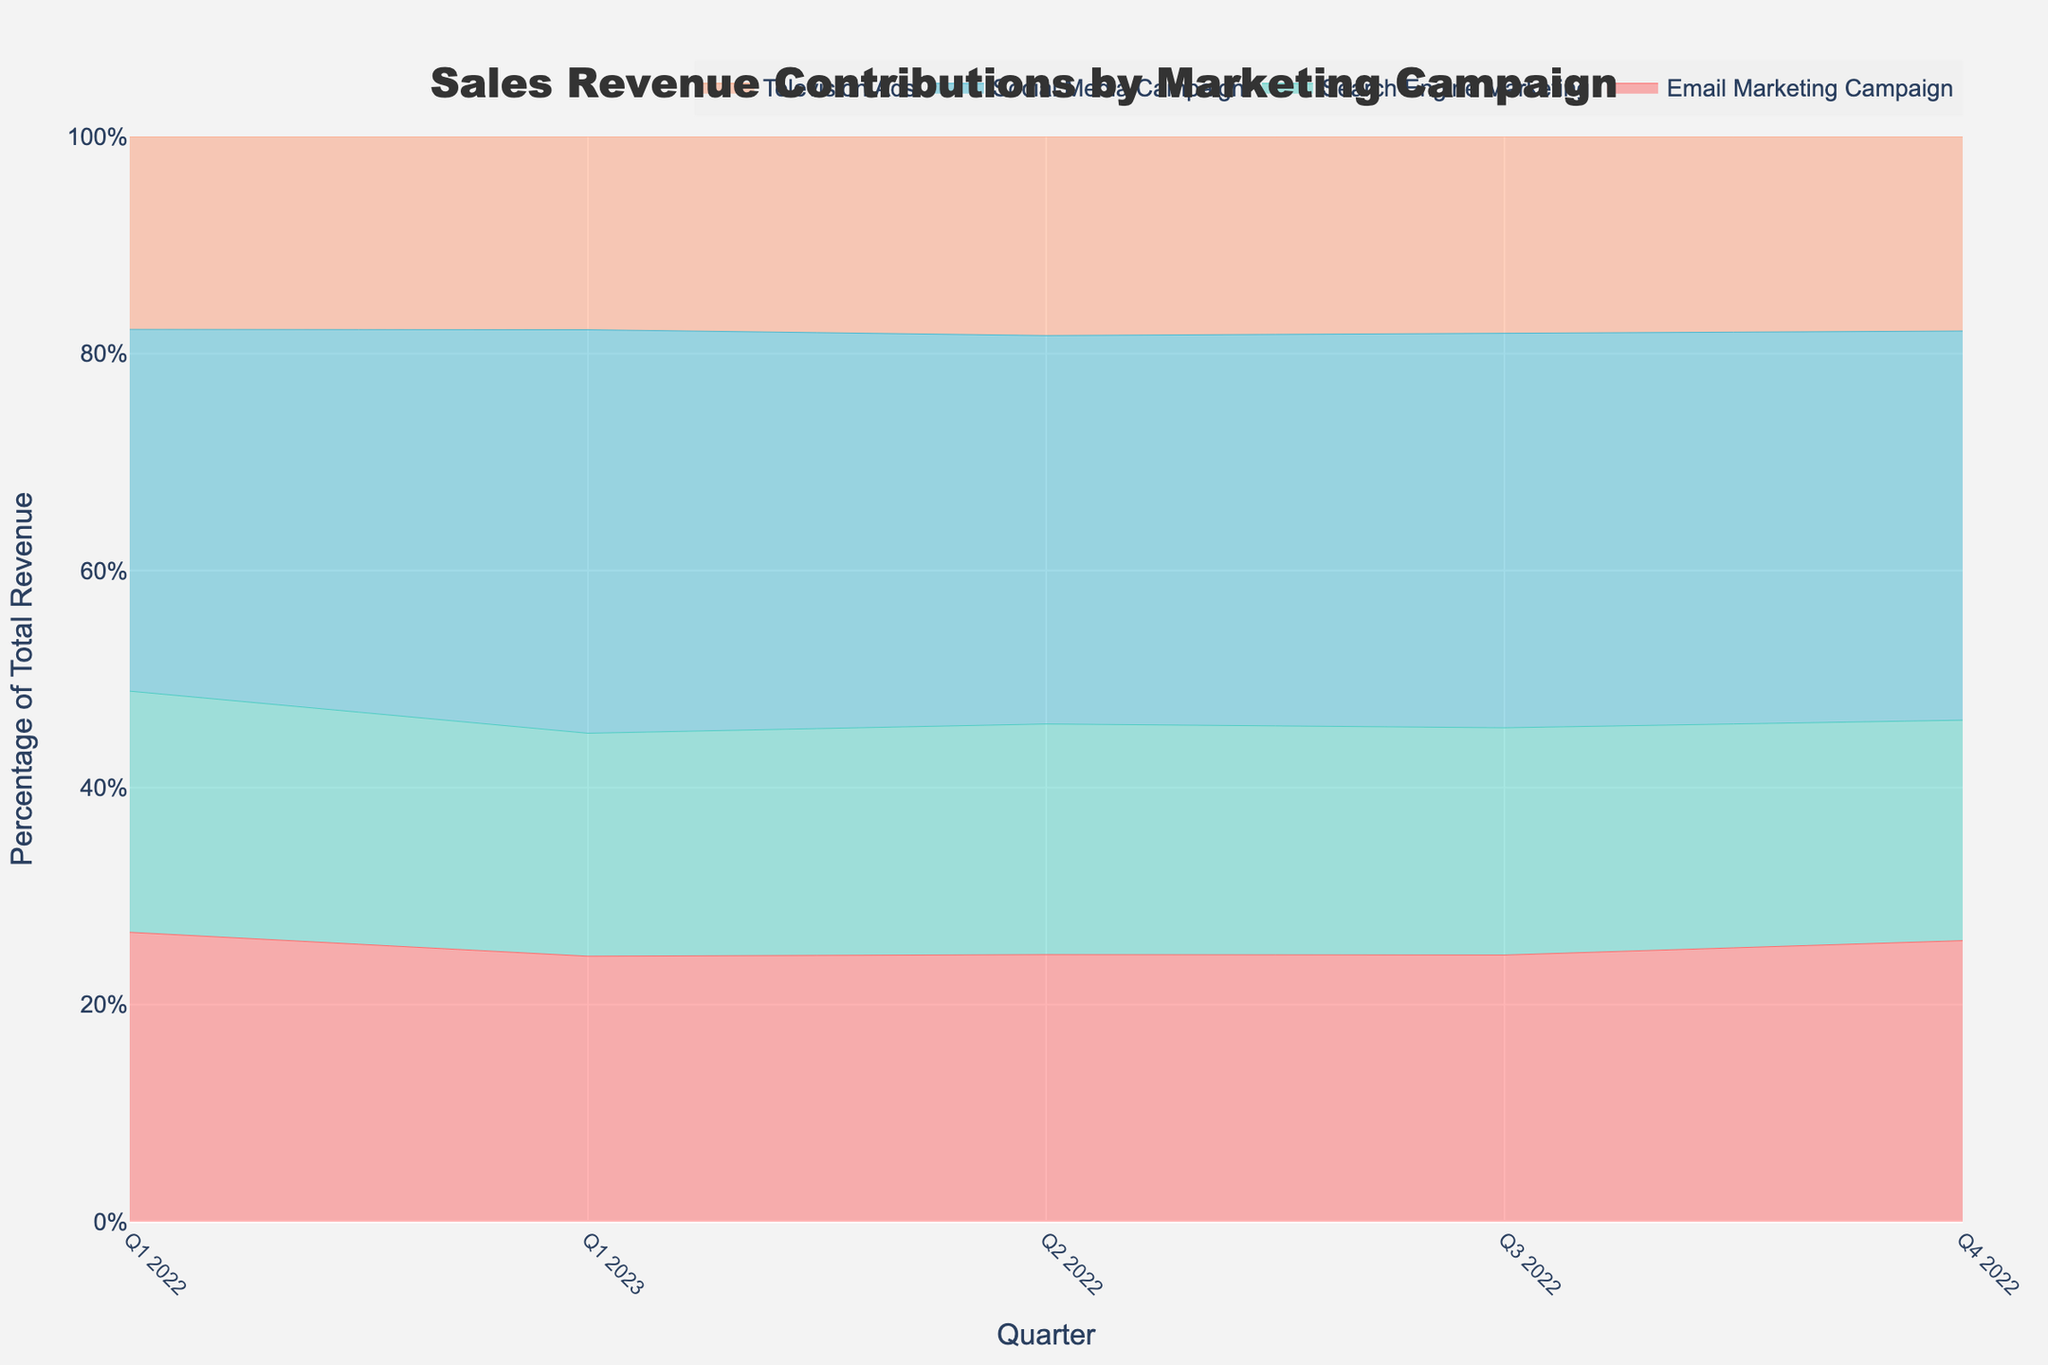What is the title of the figure? The title is usually located at the top of the figure. It reads "Sales Revenue Contributions by Marketing Campaign."
Answer: Sales Revenue Contributions by Marketing Campaign How many different marketing campaigns are represented in the figure? By examining the legend or the lines with different colors, we can see that there are four different marketing campaigns.
Answer: Four Which quarter had the highest percentage of total revenue for the Social Media Campaign? To find this, check the stream representing the Social Media Campaign and identify the quarter with the most significant area under the curve.
Answer: Q1 2023 What was the trend in percentage contribution for Television Ads from Q1 2022 to Q1 2023? Look at the bottom stream for Television Ads from left to right. The area narrows slightly, indicating a slightly decreasing trend.
Answer: Decreasing Did Search Engine Marketing's percentage contribution show any significant changes between quarters? Compare the area under the stream for Search Engine Marketing across different quarters. Noticeable changes can be identified visually.
Answer: No significant changes How much did sales revenue increase for the Social Media Campaign from Q1 2022 to Q1 2023? Look at the vertical height of the stream for Social Media Campaign at the start and the end. Calculate the difference. Q1 2022 has 150000, and Q1 2023 has 190000. So, the increase is 190000 - 150000.
Answer: 40000 Which marketing campaign contributed the least in Q2 2022? Identify the smallest stream in Q2 2022. Compare the widths of each segment visually in that quarter.
Answer: Television Ads Which two marketing campaigns have their contributions closest to each other in Q3 2022? Check the streams' widths for Q3 2022 and find any two where the areas appear nearly equal.
Answer: Email Marketing Campaign and Search Engine Marketing What can be deduced about the overall trend in total sales revenue contributions from all campaigns combined from Q1 2022 to Q1 2023? View the overall height of all streams combined. If it grows consistently, this shows an increasing trend in total revenue. If it fluctuates, interpret accordingly.
Answer: Increasing trend Which campaign shows the highest consistency in its percentage of total revenue across all quarters? Look for the stream with the most uniform width from left to right, indicating less variability.
Answer: Search Engine Marketing 